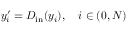Convert formula to latex. <formula><loc_0><loc_0><loc_500><loc_500>y _ { i } ^ { \prime } = D _ { i n } ( y _ { i } ) , \quad i \in ( 0 , N )</formula> 